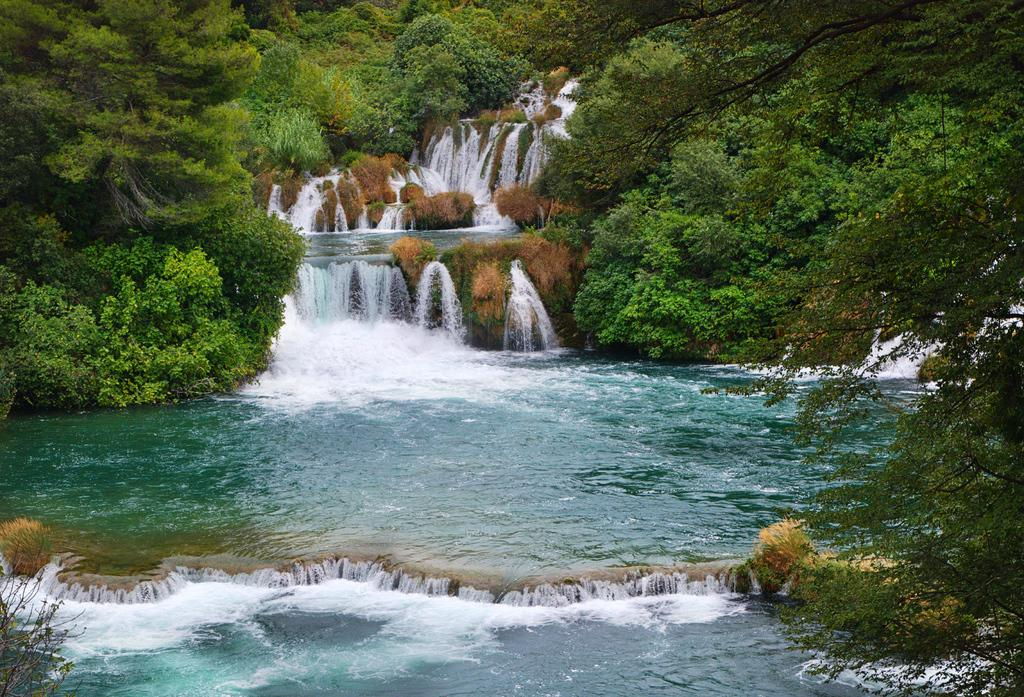What natural feature is the main subject of the image? There is a waterfall in the image. What can be seen in the background of the image? There are trees in the background of the image. What type of oven is visible in the image? There is no oven present in the image; it features a waterfall and trees. Can you tell me the relationship between the father and the waterfall in the image? There is no father or any person present in the image; it only features a waterfall and trees. 